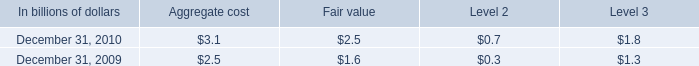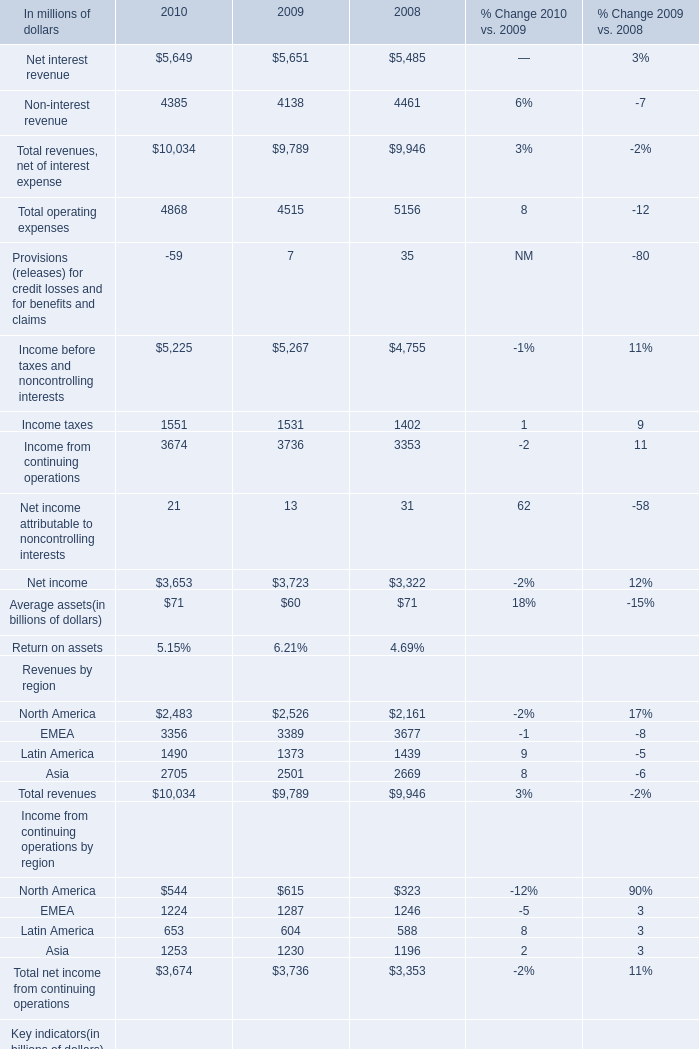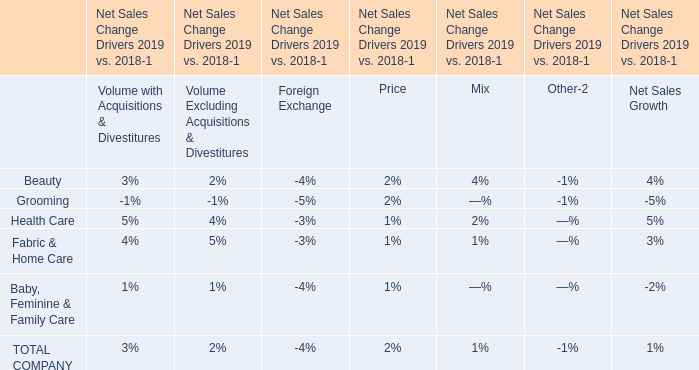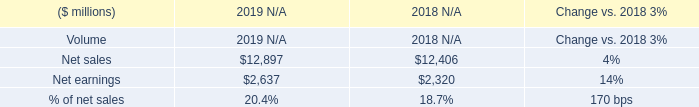What's the average of Income taxes of 2008, and Net sales of 2019 N/A ? 
Computations: ((1402.0 + 12897.0) / 2)
Answer: 7149.5. 